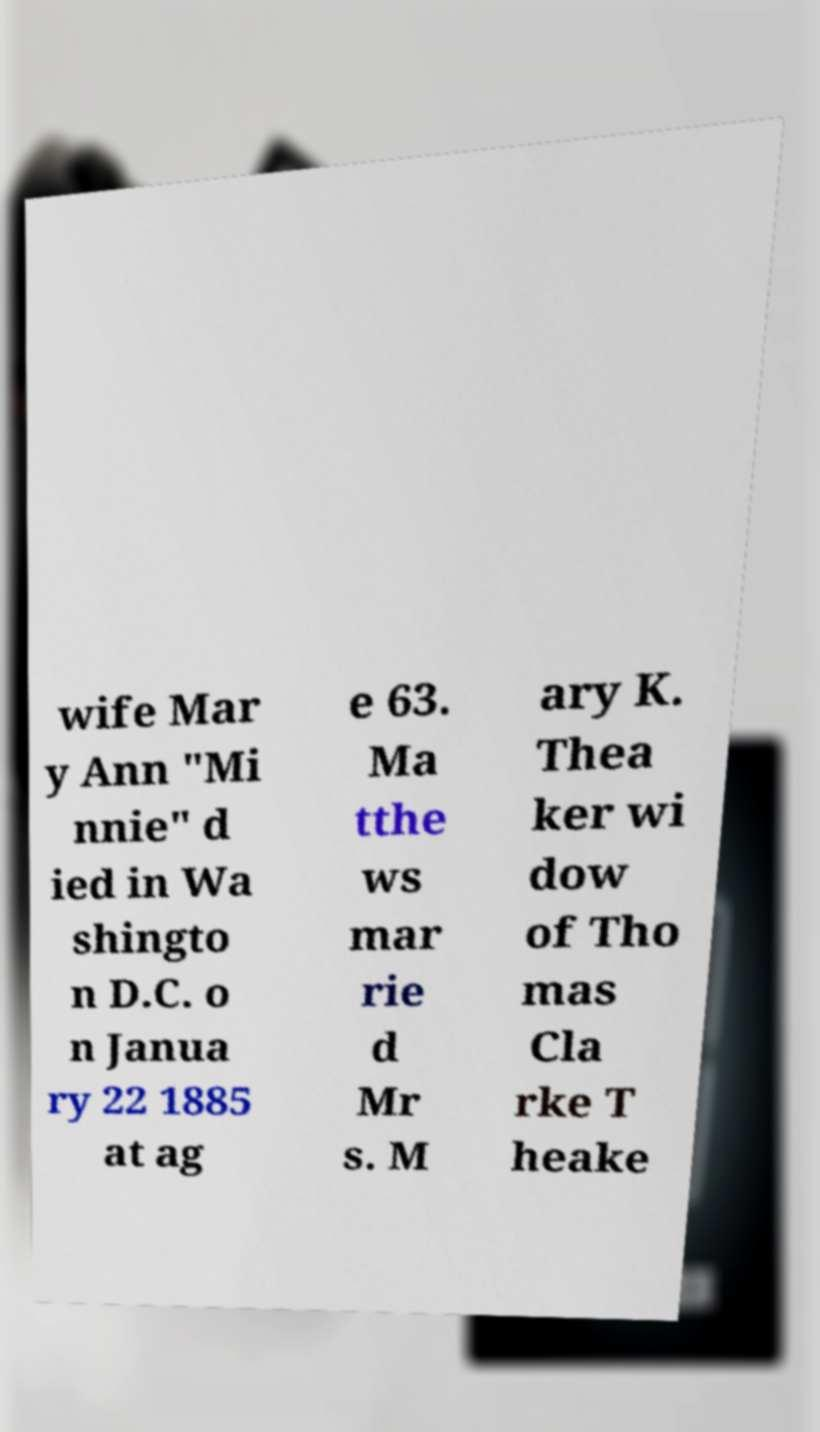Please identify and transcribe the text found in this image. wife Mar y Ann "Mi nnie" d ied in Wa shingto n D.C. o n Janua ry 22 1885 at ag e 63. Ma tthe ws mar rie d Mr s. M ary K. Thea ker wi dow of Tho mas Cla rke T heake 